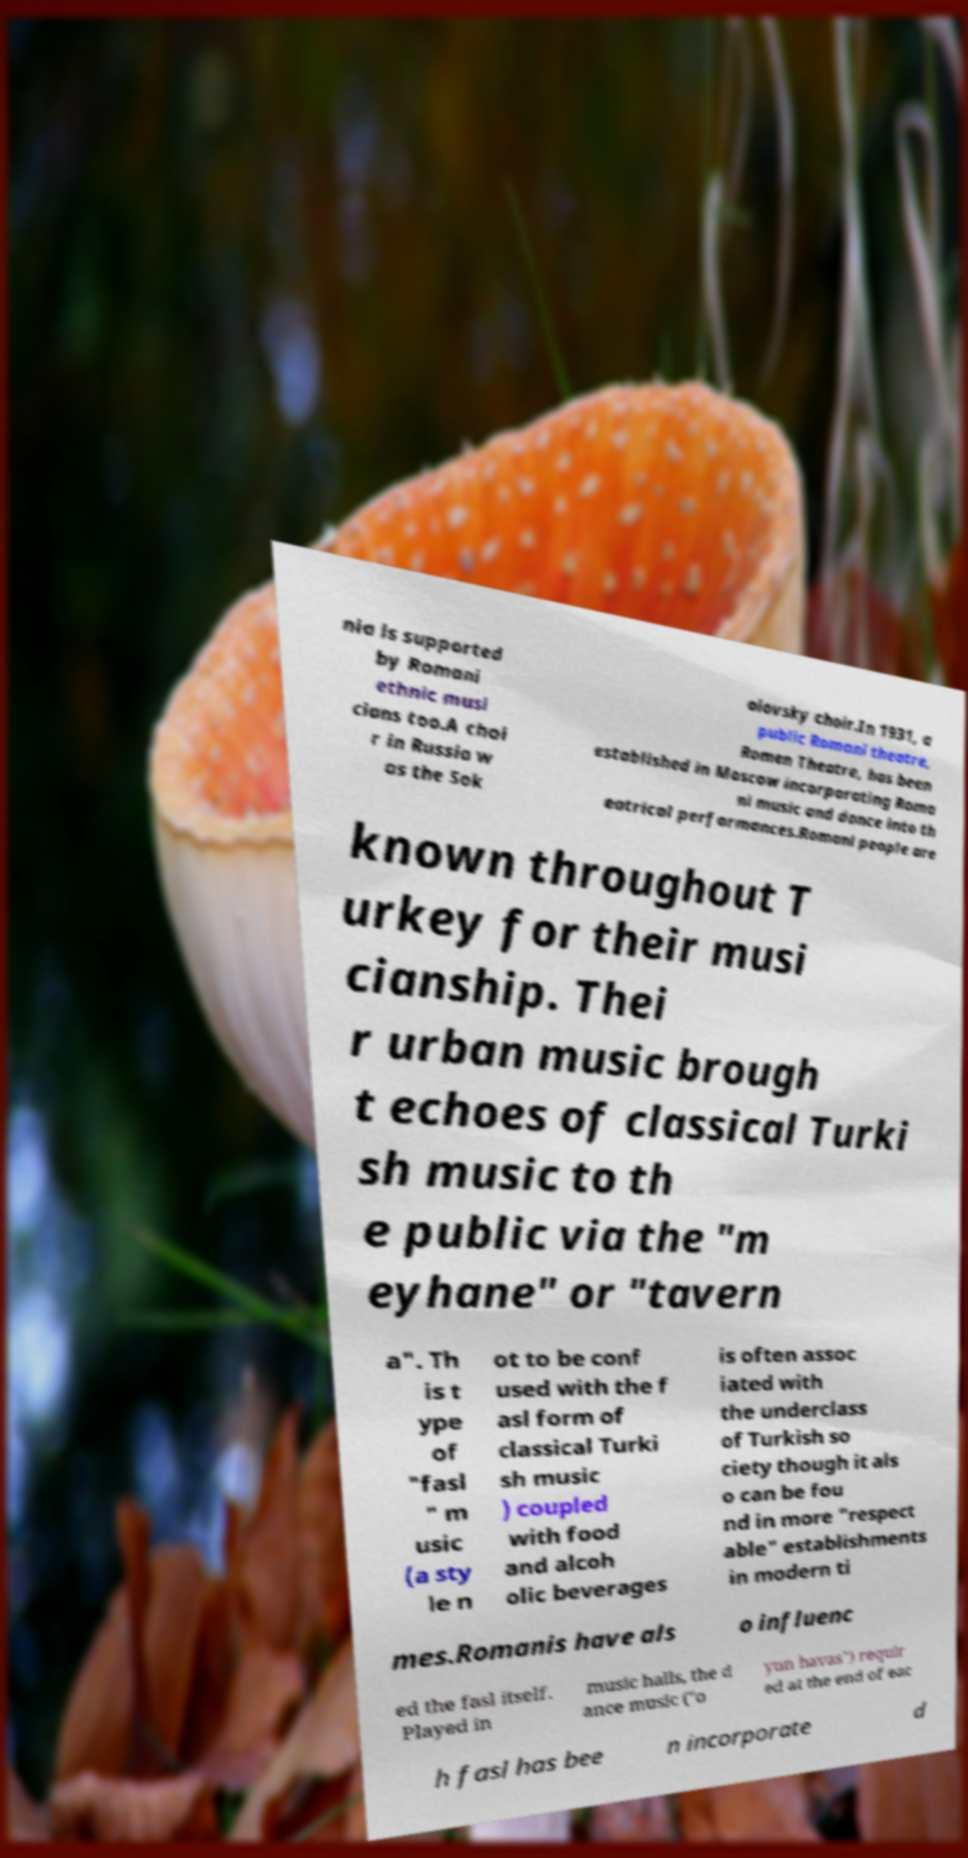Can you accurately transcribe the text from the provided image for me? nia is supported by Romani ethnic musi cians too.A choi r in Russia w as the Sok olovsky choir.In 1931, a public Romani theatre, Romen Theatre, has been established in Moscow incorporating Roma ni music and dance into th eatrical performances.Romani people are known throughout T urkey for their musi cianship. Thei r urban music brough t echoes of classical Turki sh music to th e public via the "m eyhane" or "tavern a". Th is t ype of "fasl " m usic (a sty le n ot to be conf used with the f asl form of classical Turki sh music ) coupled with food and alcoh olic beverages is often assoc iated with the underclass of Turkish so ciety though it als o can be fou nd in more "respect able" establishments in modern ti mes.Romanis have als o influenc ed the fasl itself. Played in music halls, the d ance music ("o yun havas") requir ed at the end of eac h fasl has bee n incorporate d 